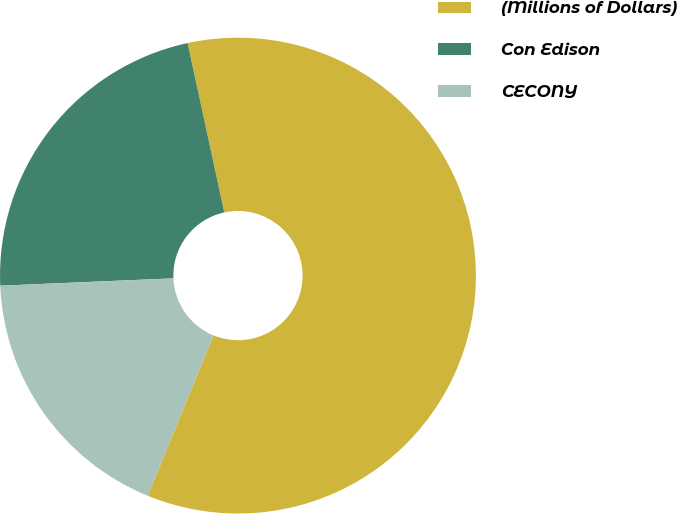Convert chart. <chart><loc_0><loc_0><loc_500><loc_500><pie_chart><fcel>(Millions of Dollars)<fcel>Con Edison<fcel>CECONY<nl><fcel>59.59%<fcel>22.28%<fcel>18.13%<nl></chart> 